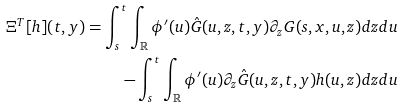Convert formula to latex. <formula><loc_0><loc_0><loc_500><loc_500>\Xi ^ { T } [ h ] ( t , y ) = \int _ { s } ^ { t } \int _ { \mathbb { R } } \phi ^ { \prime } ( u ) \hat { G } ( u , z , t , y ) \partial _ { z } G ( s , x , u , z ) d z d u \\ - \int _ { s } ^ { t } \int _ { \mathbb { R } } \phi ^ { \prime } ( u ) \partial _ { z } \hat { G } ( u , z , t , y ) h ( u , z ) d z d u</formula> 